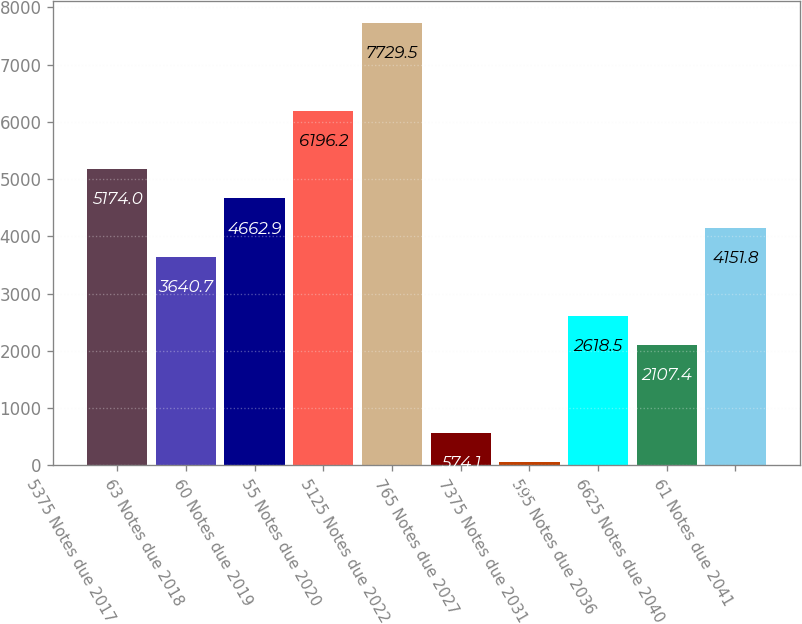Convert chart. <chart><loc_0><loc_0><loc_500><loc_500><bar_chart><fcel>5375 Notes due 2017<fcel>63 Notes due 2018<fcel>60 Notes due 2019<fcel>55 Notes due 2020<fcel>5125 Notes due 2022<fcel>765 Notes due 2027<fcel>7375 Notes due 2031<fcel>595 Notes due 2036<fcel>6625 Notes due 2040<fcel>61 Notes due 2041<nl><fcel>5174<fcel>3640.7<fcel>4662.9<fcel>6196.2<fcel>7729.5<fcel>574.1<fcel>63<fcel>2618.5<fcel>2107.4<fcel>4151.8<nl></chart> 